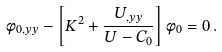<formula> <loc_0><loc_0><loc_500><loc_500>\phi _ { 0 , y y } - \left [ K ^ { 2 } + \frac { U _ { , y y } } { U - C _ { 0 } } \right ] \phi _ { 0 } = 0 \, .</formula> 